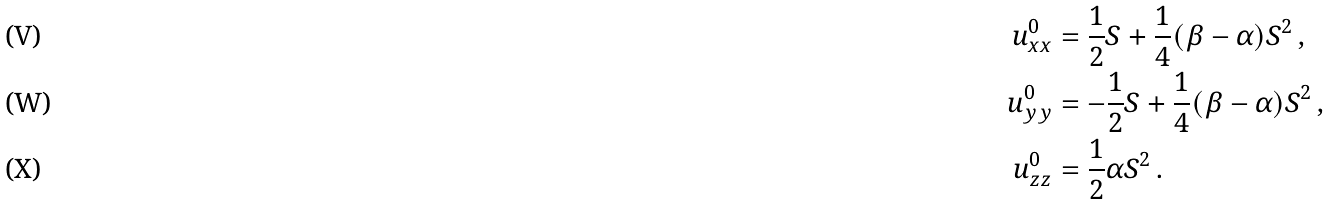Convert formula to latex. <formula><loc_0><loc_0><loc_500><loc_500>u _ { x x } ^ { 0 } & = \frac { 1 } { 2 } S + \frac { 1 } { 4 } ( \beta - \alpha ) S ^ { 2 } \, , \\ u _ { y y } ^ { 0 } & = - \frac { 1 } { 2 } S + \frac { 1 } { 4 } ( \beta - \alpha ) S ^ { 2 } \, , \\ u _ { z z } ^ { 0 } & = \frac { 1 } { 2 } \alpha S ^ { 2 } \, .</formula> 